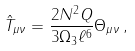Convert formula to latex. <formula><loc_0><loc_0><loc_500><loc_500>\hat { T } _ { \mu \nu } = \frac { 2 N ^ { 2 } Q } { 3 \Omega _ { 3 } \ell ^ { 6 } } \Theta _ { \mu \nu } \, ,</formula> 